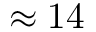<formula> <loc_0><loc_0><loc_500><loc_500>\approx 1 4</formula> 